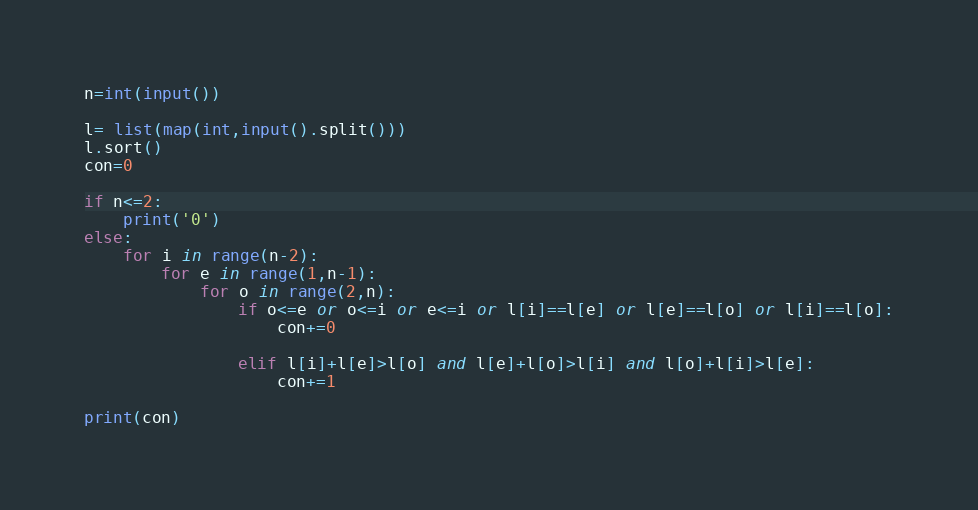<code> <loc_0><loc_0><loc_500><loc_500><_Python_>n=int(input())

l= list(map(int,input().split()))
l.sort()
con=0

if n<=2:
    print('0')
else:
    for i in range(n-2):
        for e in range(1,n-1):
            for o in range(2,n):
                if o<=e or o<=i or e<=i or l[i]==l[e] or l[e]==l[o] or l[i]==l[o]:
                    con+=0
 
                elif l[i]+l[e]>l[o] and l[e]+l[o]>l[i] and l[o]+l[i]>l[e]:
                    con+=1
                                         
print(con)</code> 